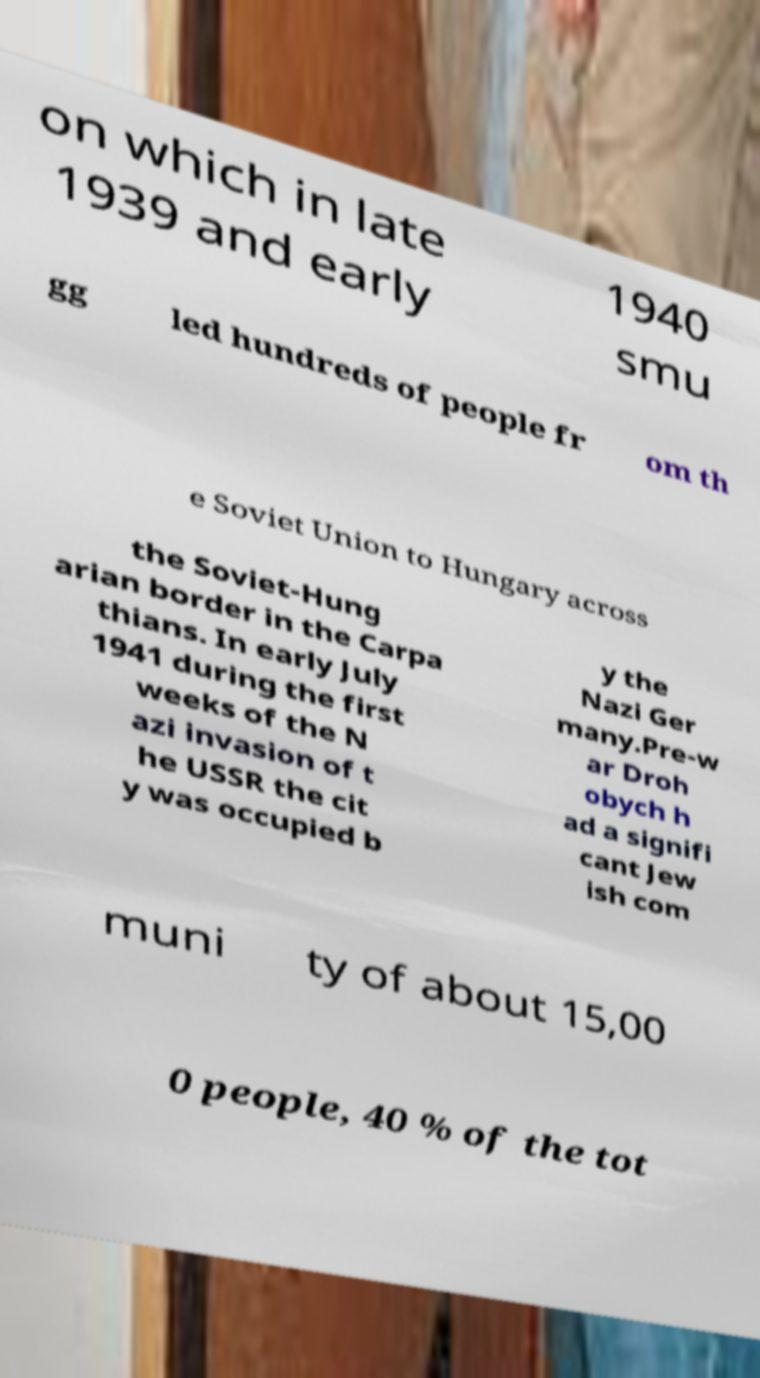Please identify and transcribe the text found in this image. on which in late 1939 and early 1940 smu gg led hundreds of people fr om th e Soviet Union to Hungary across the Soviet-Hung arian border in the Carpa thians. In early July 1941 during the first weeks of the N azi invasion of t he USSR the cit y was occupied b y the Nazi Ger many.Pre-w ar Droh obych h ad a signifi cant Jew ish com muni ty of about 15,00 0 people, 40 % of the tot 